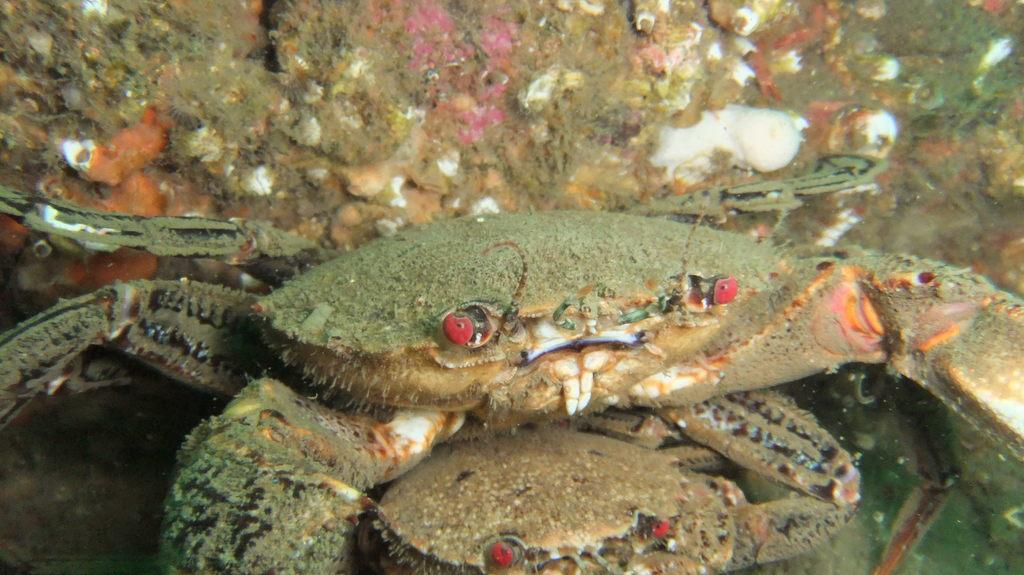What type of animals are in the image? There are crabs in the image. How do the crabs appear in the image? The crabs resemble corals in appearance. Where are the crabs located in the image? The crabs are in the water. What type of brain can be seen in the image? There is no brain present in the image; it features crabs that resemble corals in appearance. What is the weather like in the image? The provided facts do not mention the weather, so it cannot be determined from the image. 